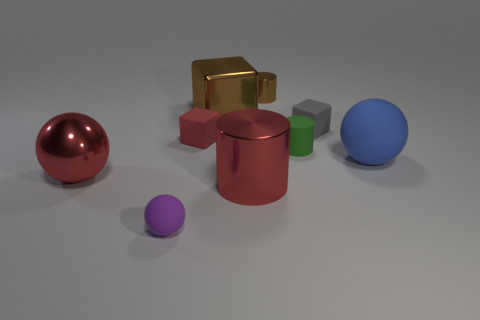Which object stands out the most to you and why? The shiny red sphere stands out the most as its reflective surface catches the light and creates a pronounced highlight, drawing the viewer's attention. Its vibrant color also contrasts strongly with the other more muted colors present in the scene. What does that tell us about the lighting in the scene? The bright highlight on the red sphere, along with visible shadows under the objects, indicates that the lighting in the scene is directional, likely coming from above. The absence of multiple shadows suggests a single or primary light source illuminating the scene. 